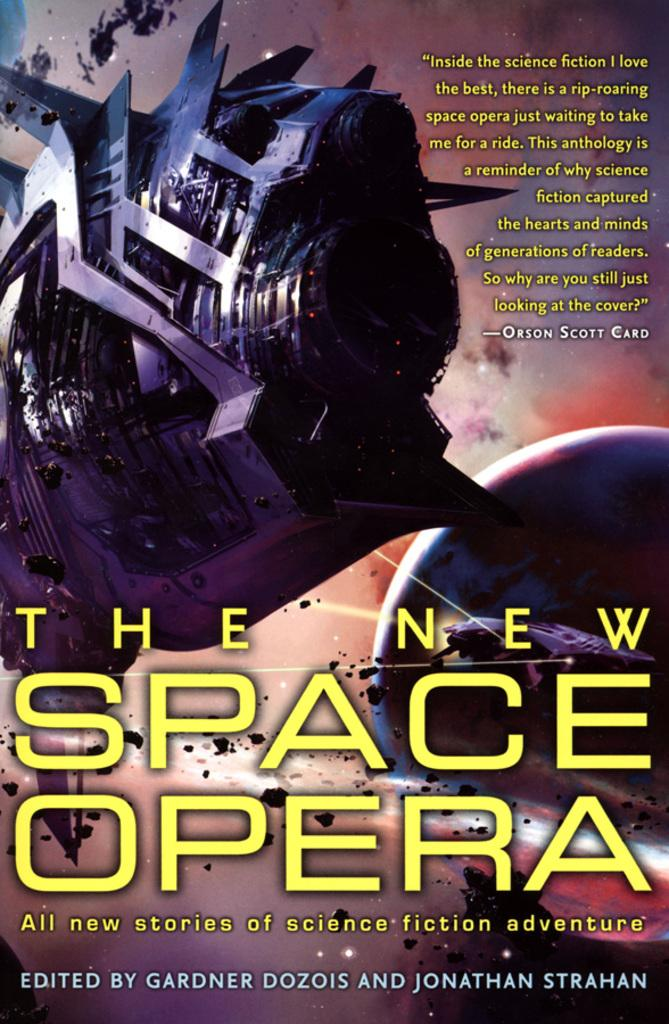What is featured on the poster in the image? The poster contains a machine and a planet. What else can be found on the poster besides the machine and planet? There is text on the poster. What type of question is being asked on the poster? There is no question present on the poster; it contains a machine, a planet, and text. 